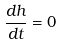Convert formula to latex. <formula><loc_0><loc_0><loc_500><loc_500>\frac { d h } { d t } = 0</formula> 